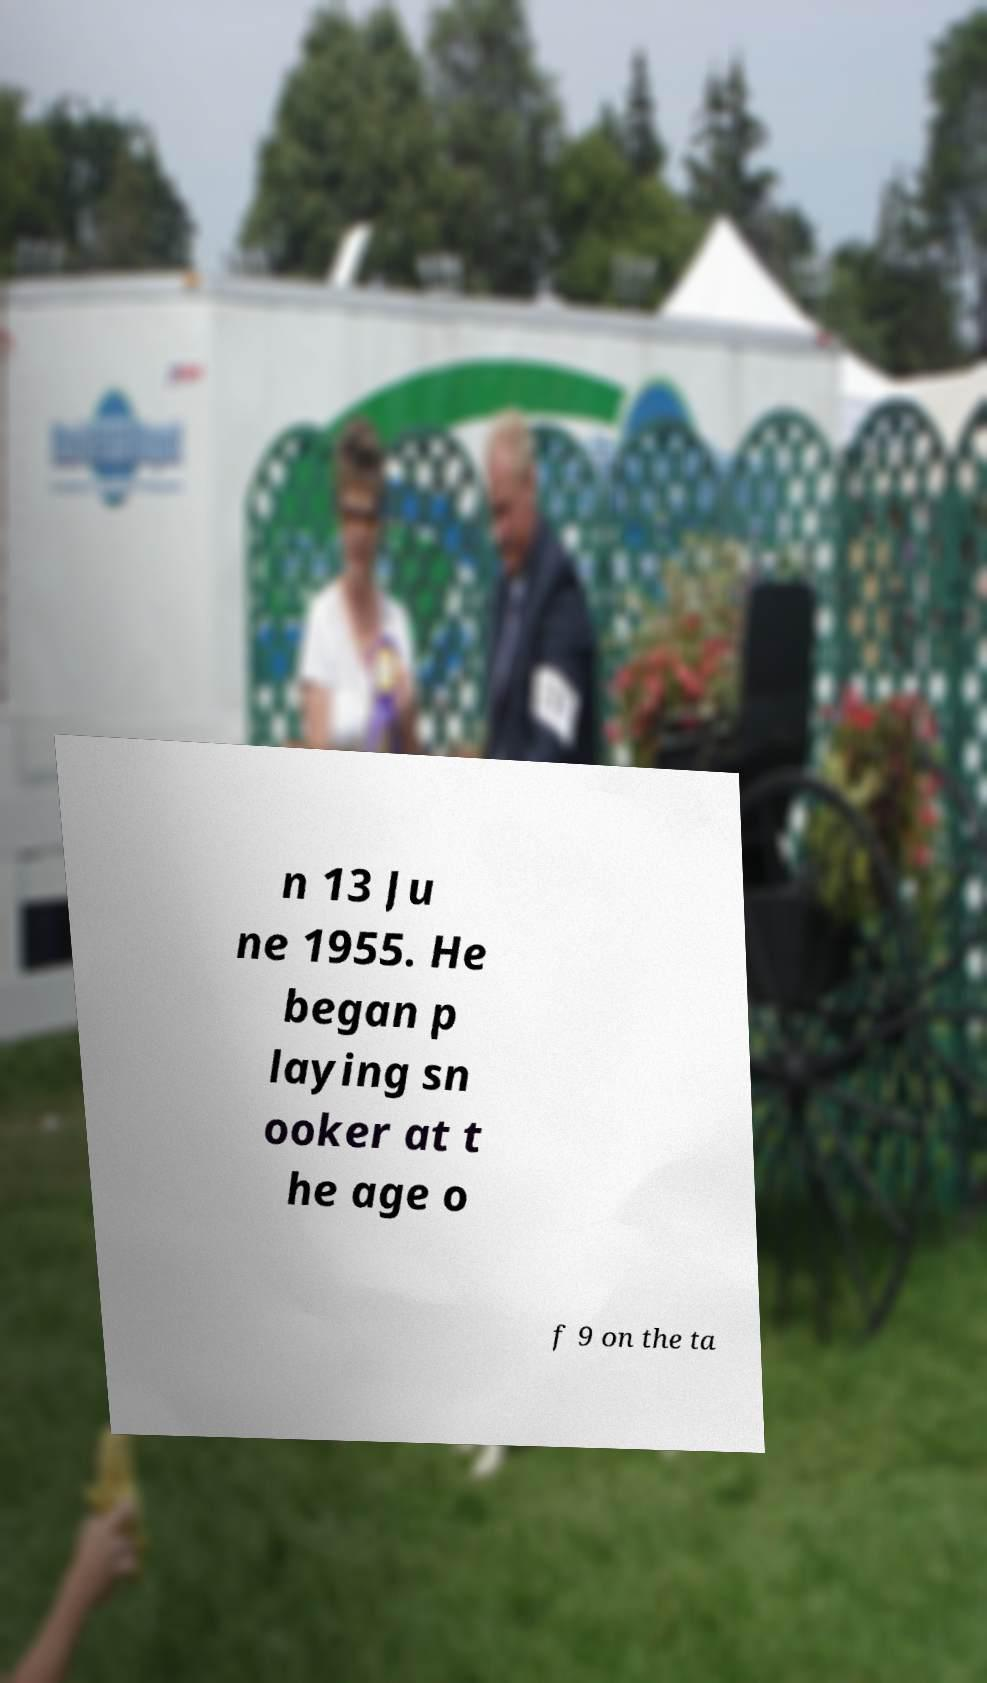Can you read and provide the text displayed in the image?This photo seems to have some interesting text. Can you extract and type it out for me? n 13 Ju ne 1955. He began p laying sn ooker at t he age o f 9 on the ta 